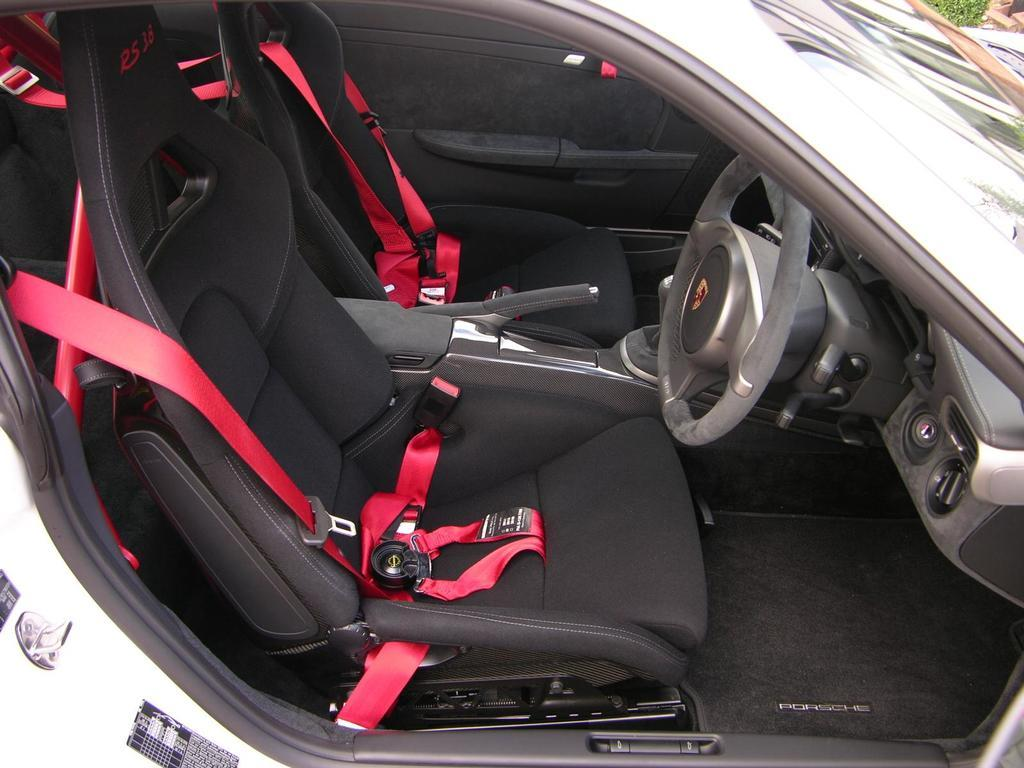What type of setting is depicted in the image? The image is an inside view of a car. What is the weight of the sock on the table in the image? There is no table or sock present in the image; it is an inside view of a car. 